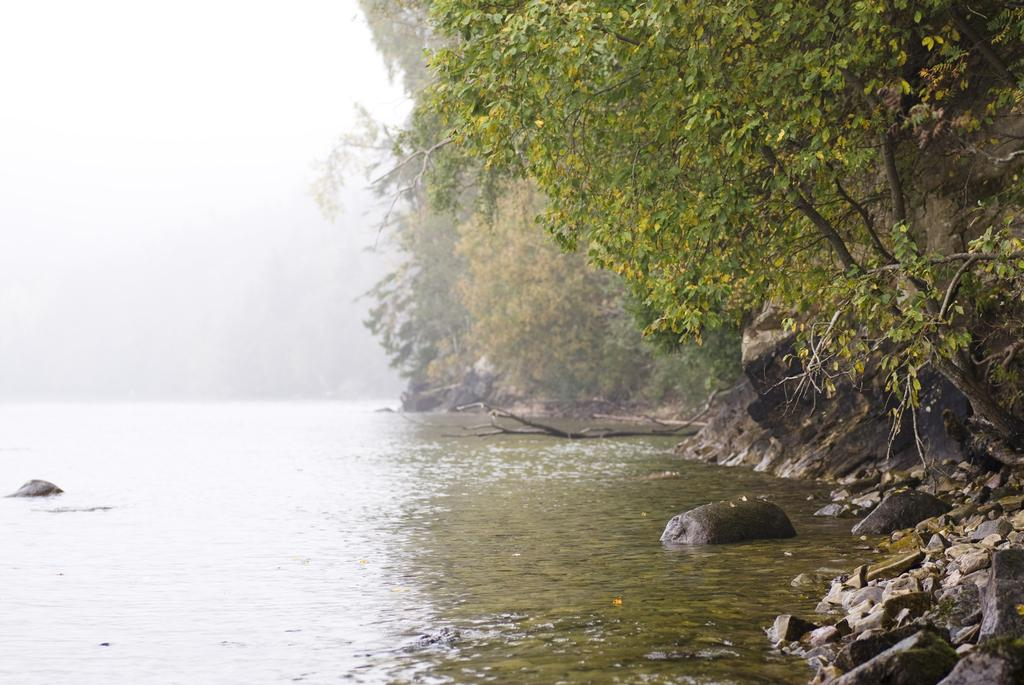What is one of the natural elements present in the image? There is water in the image. What type of objects can be found in the water? There are stones in the image. What other natural elements can be seen in the image? There are rocks and trees in the image. What is visible in the background of the image? The sky is visible in the image. Can you hear the plants laughing in the image? There are no plants or sounds present in the image, so it is not possible to hear them laughing. 